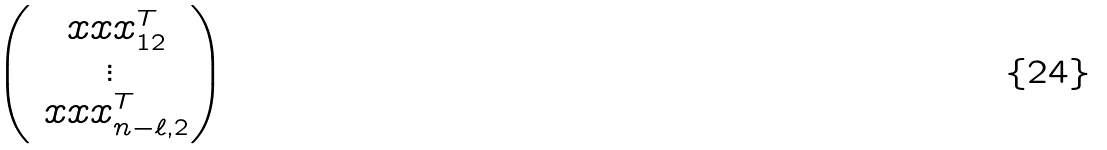Convert formula to latex. <formula><loc_0><loc_0><loc_500><loc_500>\begin{pmatrix} \ x x x _ { 1 2 } ^ { T } \\ \vdots \\ \ x x x _ { n - \ell , 2 } ^ { T } \end{pmatrix}</formula> 